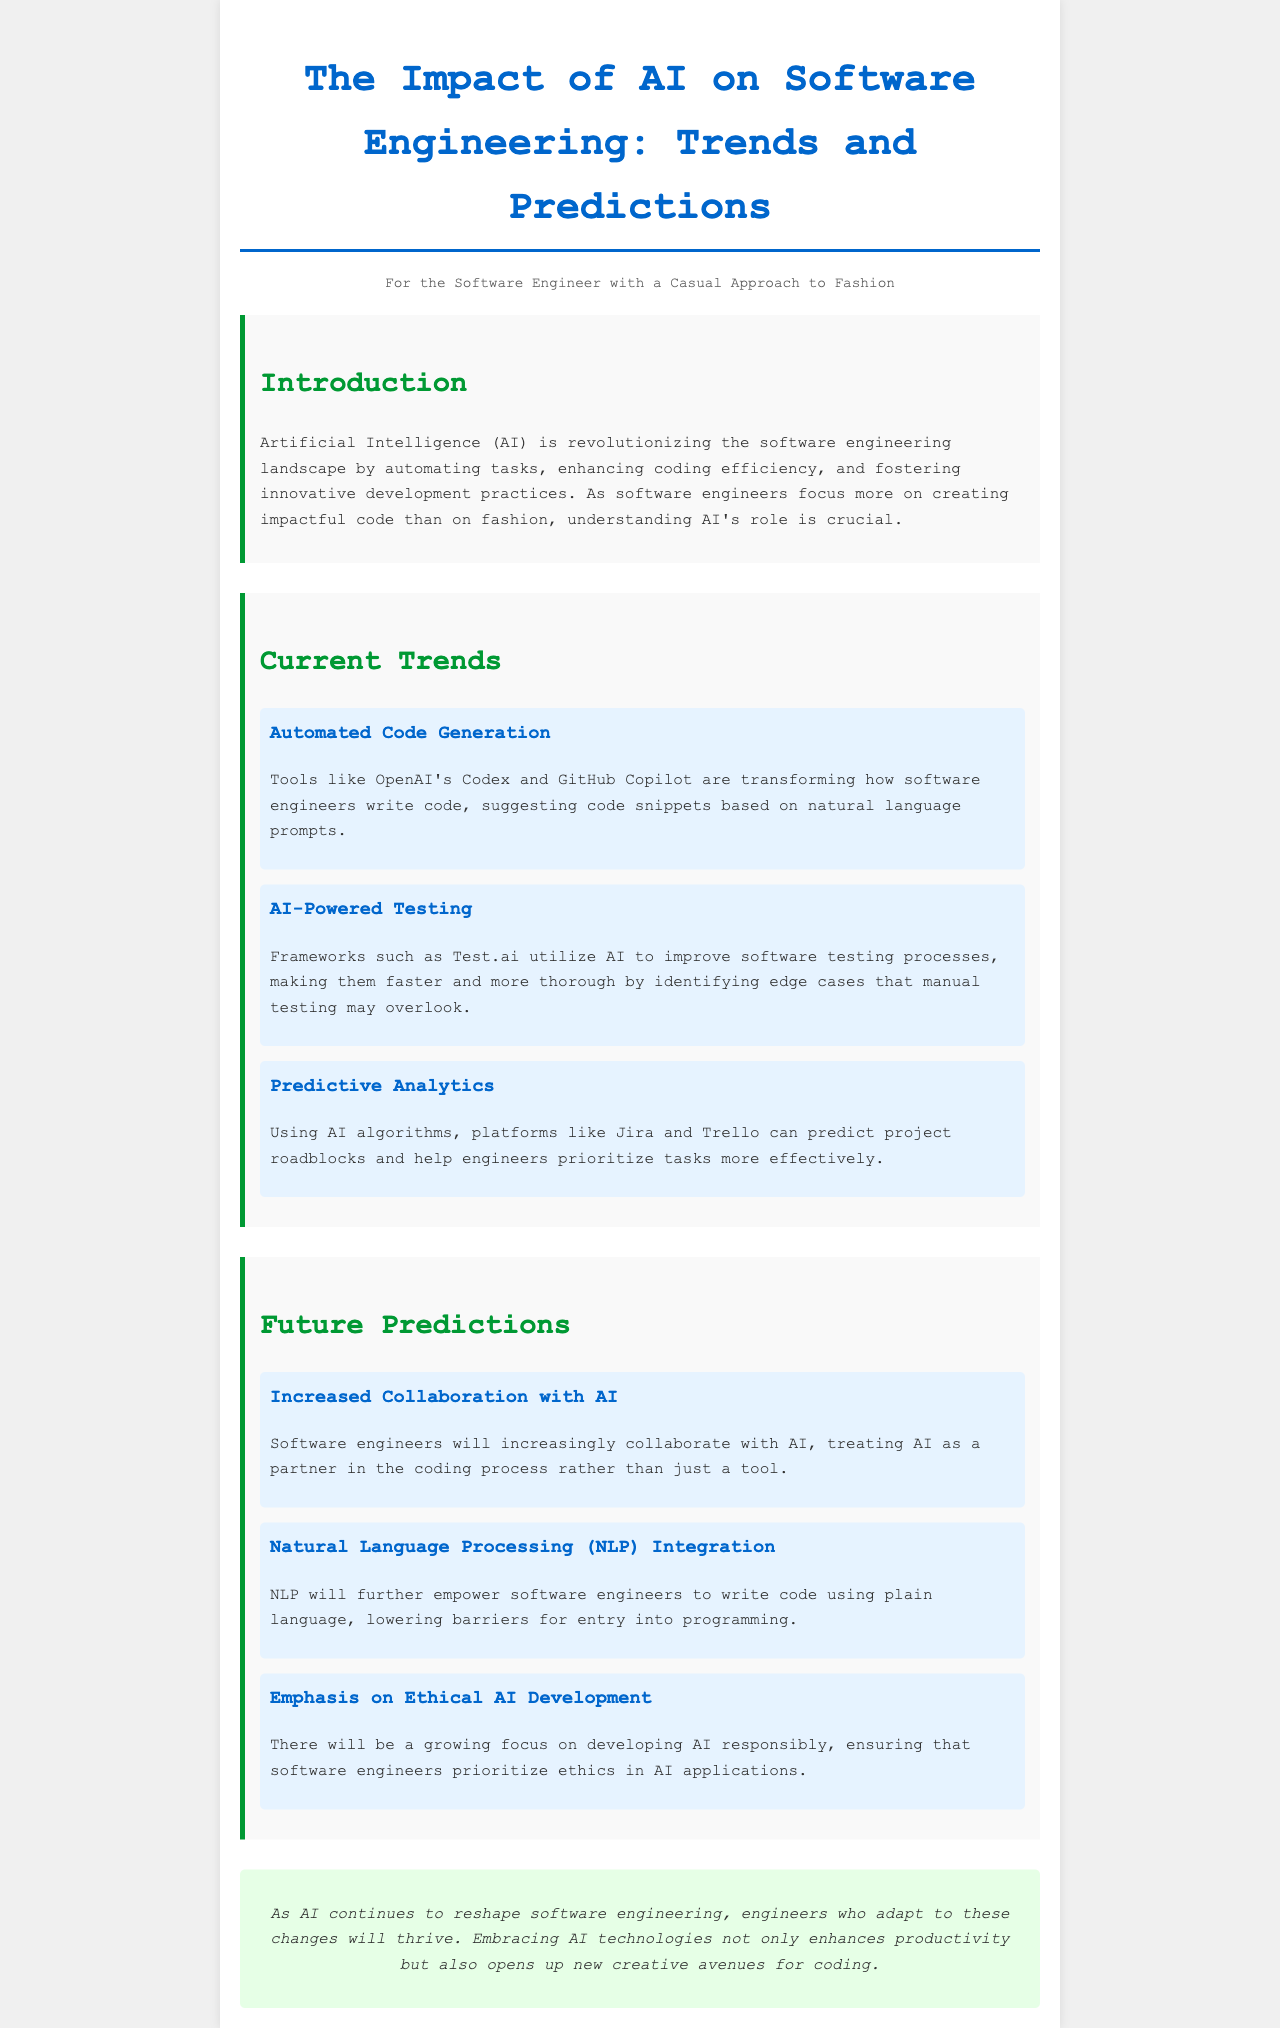What is the title of the brochure? The title is prominently displayed at the top of the document.
Answer: The Impact of AI on Software Engineering: Trends and Predictions Who are the intended readers of the document? The document specifies a persona section aimed at a specific audience.
Answer: Software Engineer with a Casual Approach to Fashion What tool is mentioned for automated code generation? The document lists specific tools in the trends section.
Answer: OpenAI's Codex What does AI-powered testing improve? The benefits of AI-powered testing are detailed in the trends section.
Answer: Testing processes What is one predicted future trend for software engineers? The predictions section provides insights about future trends in software development.
Answer: Increased Collaboration with AI Which framework is mentioned for predictive analytics? The specific platform is highlighted in the trends section.
Answer: Jira What is emphasized in the development of AI according to the predictions? Ethics in AI applications are discussed in the predictions section.
Answer: Ethical AI Development How does AI impact coding efficiency? The introduction outlines how AI affects the coding process for engineers.
Answer: By automating tasks What color is used for the section titles? The document uses different colors for various sections to enhance readability.
Answer: Green 